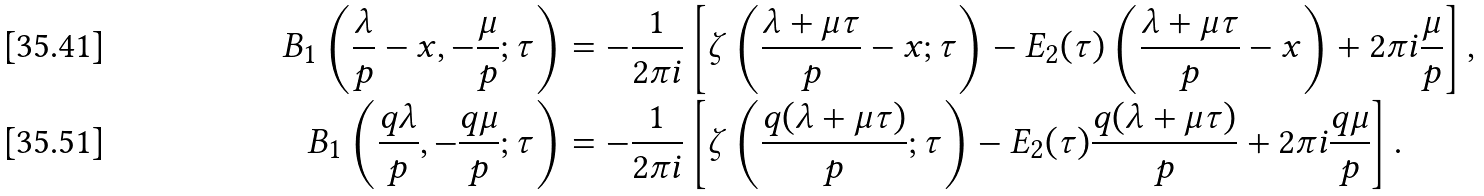<formula> <loc_0><loc_0><loc_500><loc_500>B _ { 1 } \left ( \frac { \lambda } { p } - x , - \frac { \mu } { p } ; \tau \right ) & = - \frac { 1 } { 2 \pi i } \left [ \zeta \left ( \frac { \lambda + \mu \tau } { p } - x ; \tau \right ) - E _ { 2 } ( \tau ) \left ( \frac { \lambda + \mu \tau } { p } - x \right ) + 2 \pi i \frac { \mu } { p } \right ] , \\ B _ { 1 } \left ( \frac { q \lambda } { p } , - \frac { q \mu } { p } ; \tau \right ) & = - \frac { 1 } { 2 \pi i } \left [ \zeta \left ( \frac { q ( \lambda + \mu \tau ) } { p } ; \tau \right ) - E _ { 2 } ( \tau ) \frac { q ( \lambda + \mu \tau ) } { p } + 2 \pi i \frac { q \mu } { p } \right ] .</formula> 